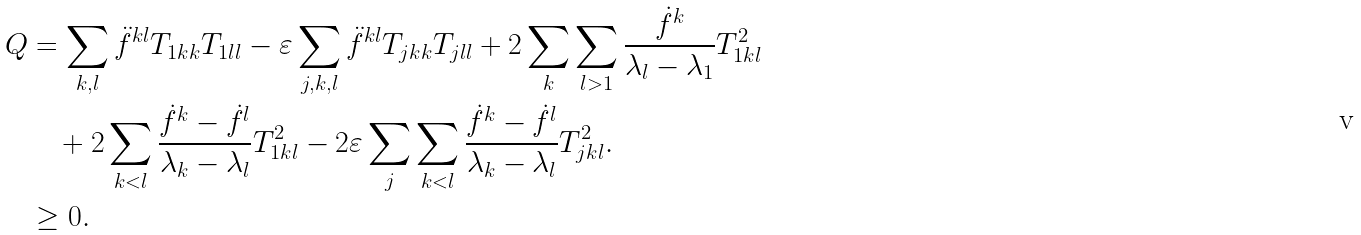Convert formula to latex. <formula><loc_0><loc_0><loc_500><loc_500>Q & = \sum _ { k , l } \ddot { f } ^ { k l } T _ { 1 k k } T _ { 1 l l } - \varepsilon \sum _ { j , k , l } \ddot { f } ^ { k l } T _ { j k k } T _ { j l l } + 2 \sum _ { k } \sum _ { l > 1 } \frac { \dot { f } ^ { k } } { \lambda _ { l } - \lambda _ { 1 } } T _ { 1 k l } ^ { 2 } \\ & \quad \null + 2 \sum _ { k < l } \frac { \dot { f } ^ { k } - \dot { f } ^ { l } } { \lambda _ { k } - \lambda _ { l } } T _ { 1 k l } ^ { 2 } - 2 \varepsilon \sum _ { j } \sum _ { k < l } \frac { \dot { f } ^ { k } - \dot { f } ^ { l } } { \lambda _ { k } - \lambda _ { l } } T _ { j k l } ^ { 2 } . \\ & \geq 0 .</formula> 